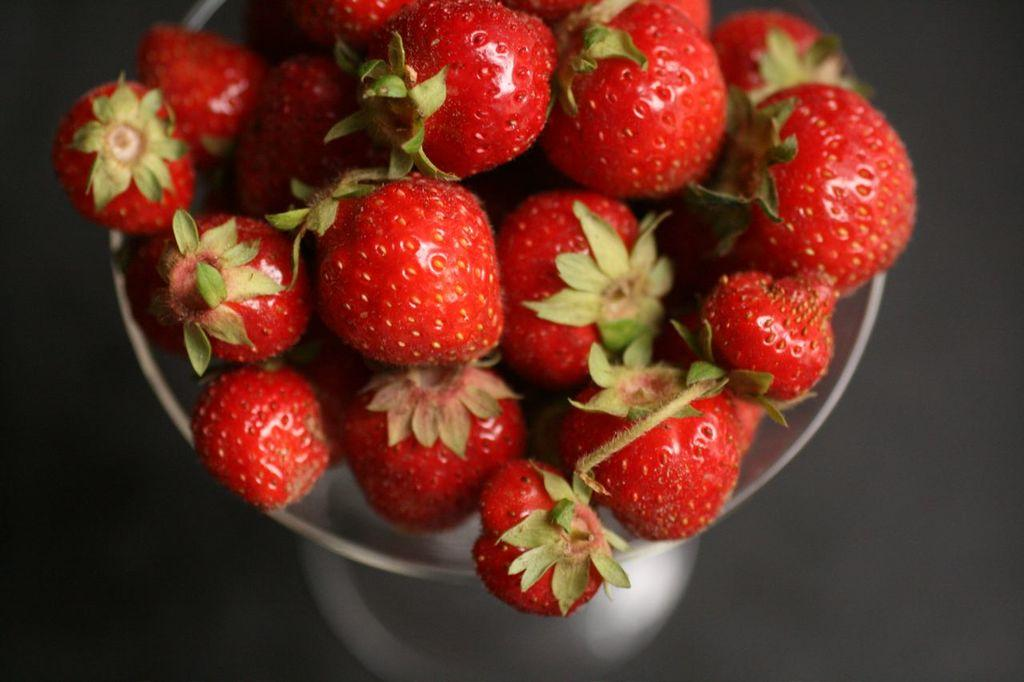What type of fruit is in the jar in the image? There are strawberries in a jar in the image. What is located at the bottom of the image? There is a table at the bottom of the image. What color is the nail on the table in the image? There is no nail present on the table in the image. How does the mailbox balance on the strawberries in the image? There is no mailbox present in the image, so it cannot balance on the strawberries. 